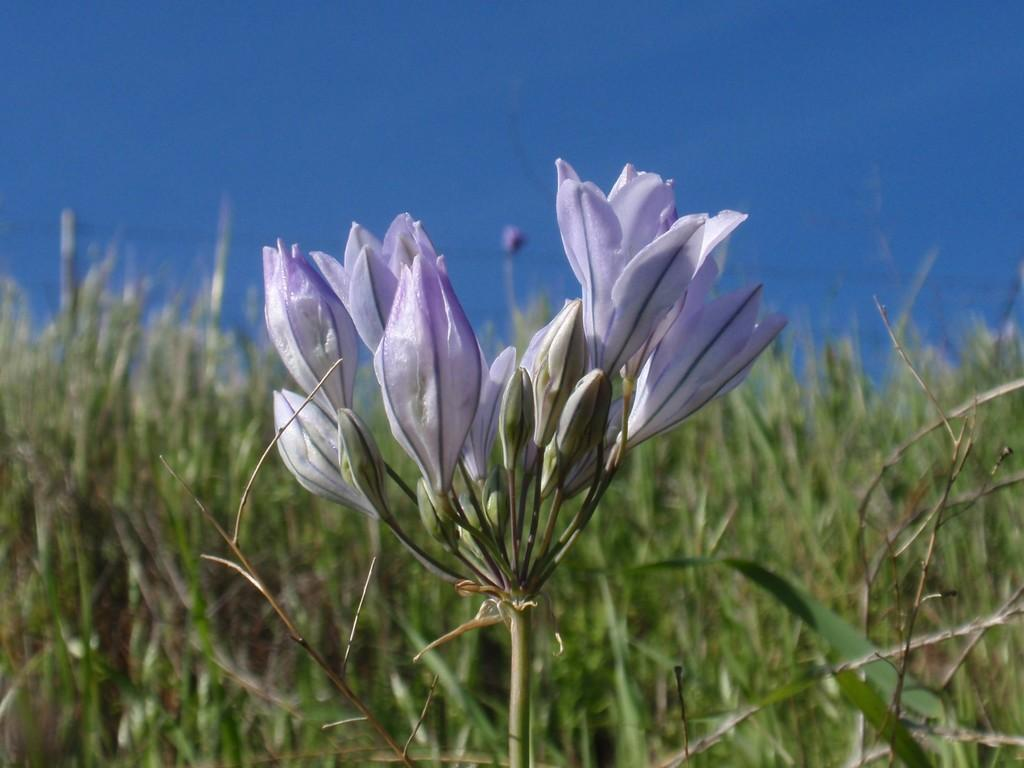What type of plant life is present in the image? There are flowers, flower buds, and stems in the image. Can you describe the background of the image? The background has a blurred view, with plants and the sky visible. What part of the plants can be seen in the image? The flowers, flower buds, and stems are visible in the image. What type of unit can be seen sailing on the stone in the image? There is no unit, sailing, or stone present in the image; it features flowers, flower buds, and stems with a blurred background of plants and the sky. 